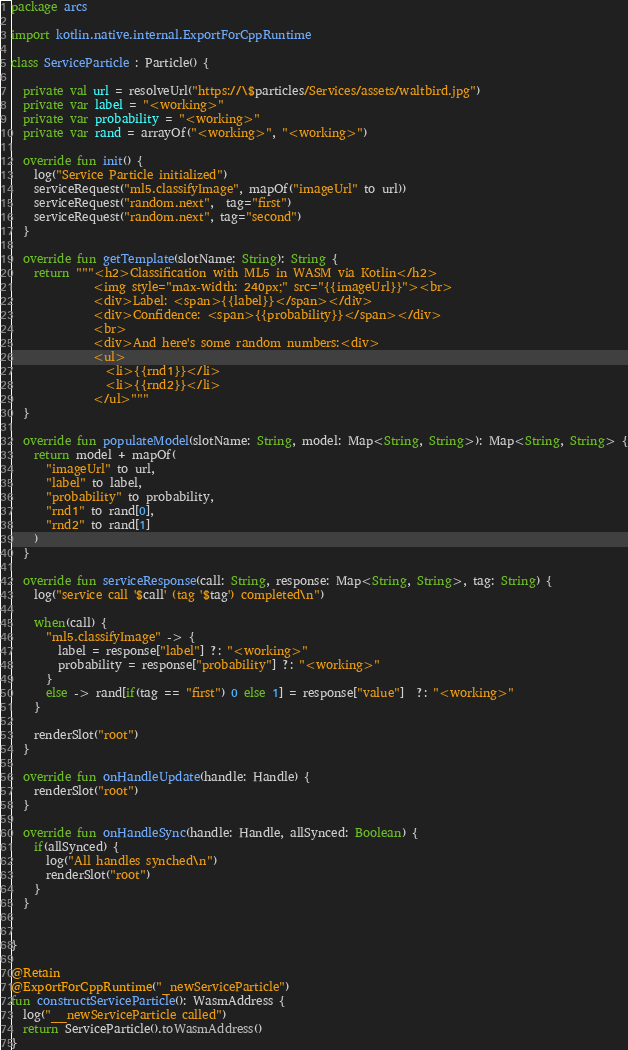<code> <loc_0><loc_0><loc_500><loc_500><_Kotlin_>package arcs

import kotlin.native.internal.ExportForCppRuntime

class ServiceParticle : Particle() {

  private val url = resolveUrl("https://\$particles/Services/assets/waltbird.jpg")
  private var label = "<working>"
  private var probability = "<working>"
  private var rand = arrayOf("<working>", "<working>")

  override fun init() {
    log("Service Particle initialized")
    serviceRequest("ml5.classifyImage", mapOf("imageUrl" to url))
    serviceRequest("random.next",  tag="first")
    serviceRequest("random.next", tag="second")
  }

  override fun getTemplate(slotName: String): String {
    return """<h2>Classification with ML5 in WASM via Kotlin</h2>
              <img style="max-width: 240px;" src="{{imageUrl}}"><br>
              <div>Label: <span>{{label}}</span></div>
              <div>Confidence: <span>{{probability}}</span></div>
              <br>
              <div>And here's some random numbers:<div>
              <ul>
                <li>{{rnd1}}</li>
                <li>{{rnd2}}</li>
              </ul>"""
  }

  override fun populateModel(slotName: String, model: Map<String, String>): Map<String, String> {
    return model + mapOf(
      "imageUrl" to url,
      "label" to label,
      "probability" to probability,
      "rnd1" to rand[0],
      "rnd2" to rand[1]
    )
  }

  override fun serviceResponse(call: String, response: Map<String, String>, tag: String) {
    log("service call '$call' (tag '$tag') completed\n")

    when(call) {
      "ml5.classifyImage" -> {
        label = response["label"] ?: "<working>"
        probability = response["probability"] ?: "<working>"
      }
      else -> rand[if(tag == "first") 0 else 1] = response["value"]  ?: "<working>"
    }

    renderSlot("root")
  }

  override fun onHandleUpdate(handle: Handle) {
    renderSlot("root")
  }

  override fun onHandleSync(handle: Handle, allSynced: Boolean) {
    if(allSynced) {
      log("All handles synched\n")
      renderSlot("root")
    }
  }


}

@Retain
@ExportForCppRuntime("_newServiceParticle")
fun constructServiceParticle(): WasmAddress {
  log("__newServiceParticle called")
  return ServiceParticle().toWasmAddress()
}
</code> 